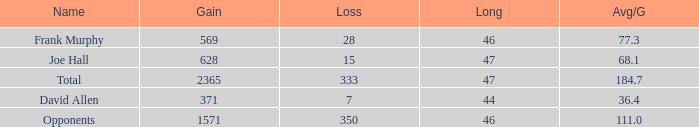How much Avg/G has a Gain smaller than 1571, and a Long smaller than 46? 1.0. 